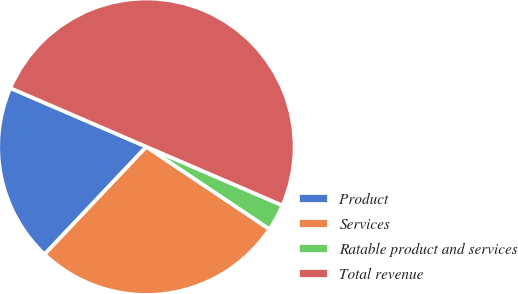Convert chart. <chart><loc_0><loc_0><loc_500><loc_500><pie_chart><fcel>Product<fcel>Services<fcel>Ratable product and services<fcel>Total revenue<nl><fcel>19.42%<fcel>27.67%<fcel>2.91%<fcel>50.0%<nl></chart> 